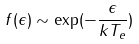Convert formula to latex. <formula><loc_0><loc_0><loc_500><loc_500>f ( \epsilon ) \sim \exp ( - \frac { \epsilon } { k T _ { e } } )</formula> 